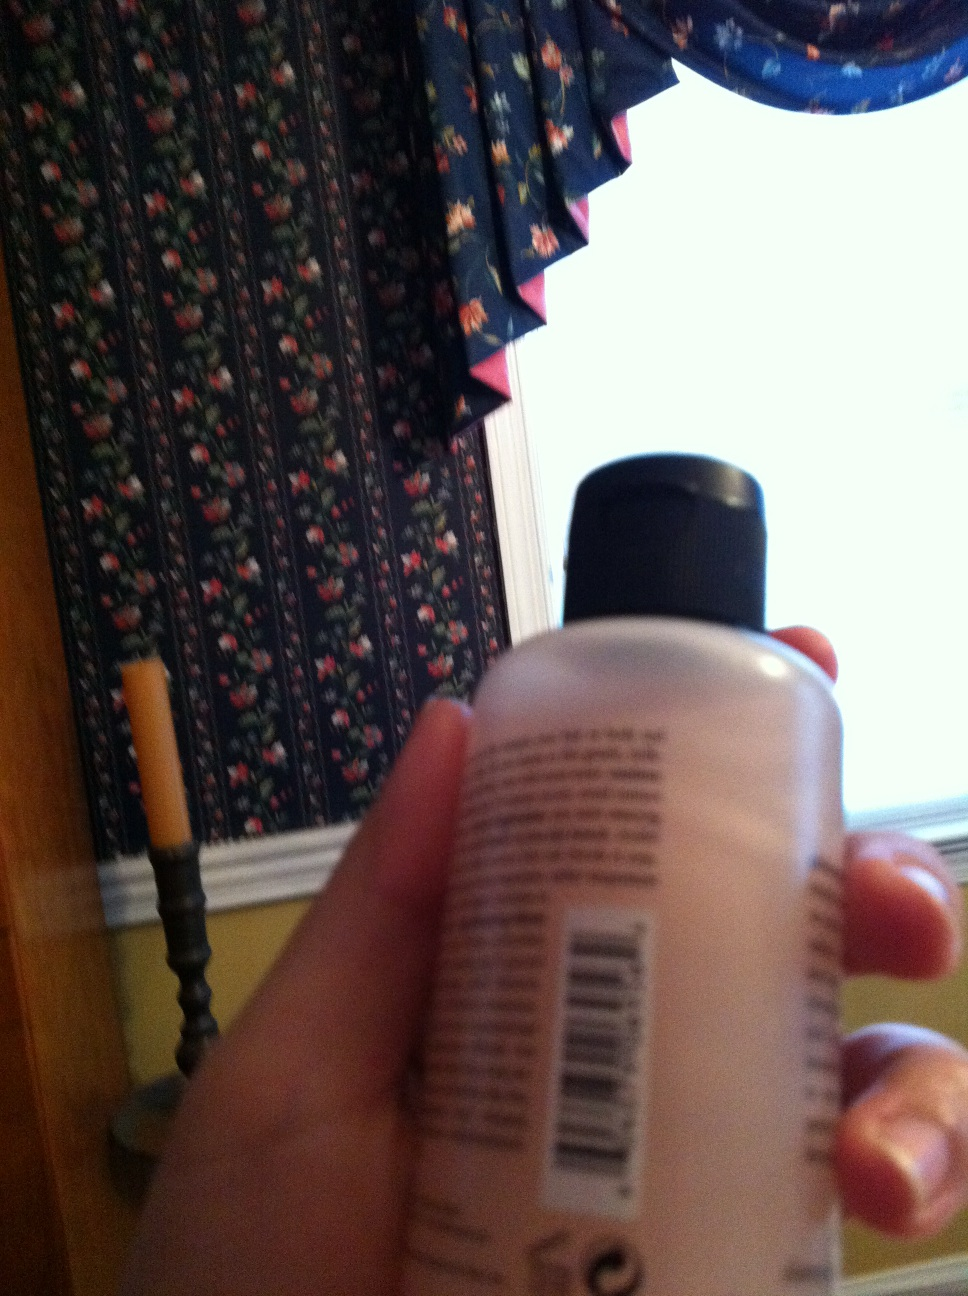Describe a long excursion that revolves around the bottle in the image. Imagine embarking on a journey to discover the origins and history of the bottle itself. Starting in a bustling city, the protagonist traces back the manufacturing process of the lotion, visiting factories and meeting the chemists who designed its formula. Each interaction reveals more about the meticulous care taken in selecting ingredients and the stories behind each component. The journey then shifts to various homes and personal spaces where this lotion has been a part of daily routines, capturing heartfelt stories of self-care and wellness. Throughout the excursion, the protagonist learns about different cultures and practices, illustrating how a simple bottle of lotion can connect disparate lives in the shared pursuit of comfort and care. 